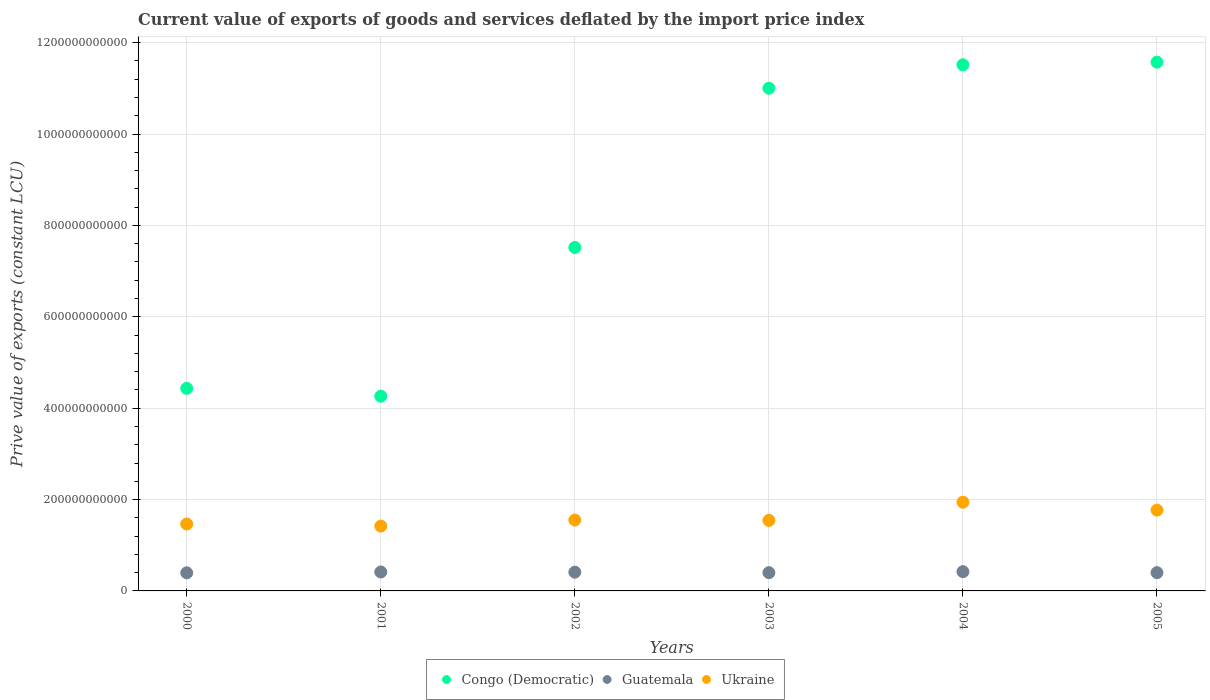What is the prive value of exports in Ukraine in 2002?
Your answer should be very brief. 1.55e+11. Across all years, what is the maximum prive value of exports in Ukraine?
Your response must be concise. 1.94e+11. Across all years, what is the minimum prive value of exports in Guatemala?
Offer a very short reply. 3.96e+1. In which year was the prive value of exports in Congo (Democratic) minimum?
Provide a succinct answer. 2001. What is the total prive value of exports in Guatemala in the graph?
Offer a terse response. 2.44e+11. What is the difference between the prive value of exports in Ukraine in 2001 and that in 2003?
Make the answer very short. -1.25e+1. What is the difference between the prive value of exports in Guatemala in 2005 and the prive value of exports in Ukraine in 2001?
Provide a short and direct response. -1.02e+11. What is the average prive value of exports in Congo (Democratic) per year?
Offer a terse response. 8.38e+11. In the year 2004, what is the difference between the prive value of exports in Guatemala and prive value of exports in Congo (Democratic)?
Provide a succinct answer. -1.11e+12. In how many years, is the prive value of exports in Guatemala greater than 640000000000 LCU?
Give a very brief answer. 0. What is the ratio of the prive value of exports in Guatemala in 2001 to that in 2003?
Provide a short and direct response. 1.04. Is the difference between the prive value of exports in Guatemala in 2000 and 2001 greater than the difference between the prive value of exports in Congo (Democratic) in 2000 and 2001?
Provide a succinct answer. No. What is the difference between the highest and the second highest prive value of exports in Guatemala?
Keep it short and to the point. 7.23e+08. What is the difference between the highest and the lowest prive value of exports in Congo (Democratic)?
Ensure brevity in your answer.  7.31e+11. In how many years, is the prive value of exports in Congo (Democratic) greater than the average prive value of exports in Congo (Democratic) taken over all years?
Ensure brevity in your answer.  3. Is the prive value of exports in Congo (Democratic) strictly greater than the prive value of exports in Guatemala over the years?
Make the answer very short. Yes. How many dotlines are there?
Your answer should be compact. 3. What is the difference between two consecutive major ticks on the Y-axis?
Give a very brief answer. 2.00e+11. Does the graph contain grids?
Provide a short and direct response. Yes. Where does the legend appear in the graph?
Provide a short and direct response. Bottom center. How many legend labels are there?
Offer a very short reply. 3. How are the legend labels stacked?
Ensure brevity in your answer.  Horizontal. What is the title of the graph?
Keep it short and to the point. Current value of exports of goods and services deflated by the import price index. Does "South Asia" appear as one of the legend labels in the graph?
Give a very brief answer. No. What is the label or title of the X-axis?
Provide a short and direct response. Years. What is the label or title of the Y-axis?
Ensure brevity in your answer.  Prive value of exports (constant LCU). What is the Prive value of exports (constant LCU) of Congo (Democratic) in 2000?
Offer a very short reply. 4.43e+11. What is the Prive value of exports (constant LCU) of Guatemala in 2000?
Your answer should be very brief. 3.96e+1. What is the Prive value of exports (constant LCU) of Ukraine in 2000?
Offer a terse response. 1.47e+11. What is the Prive value of exports (constant LCU) in Congo (Democratic) in 2001?
Keep it short and to the point. 4.26e+11. What is the Prive value of exports (constant LCU) in Guatemala in 2001?
Your answer should be very brief. 4.15e+1. What is the Prive value of exports (constant LCU) of Ukraine in 2001?
Keep it short and to the point. 1.42e+11. What is the Prive value of exports (constant LCU) in Congo (Democratic) in 2002?
Your answer should be very brief. 7.52e+11. What is the Prive value of exports (constant LCU) in Guatemala in 2002?
Provide a short and direct response. 4.10e+1. What is the Prive value of exports (constant LCU) of Ukraine in 2002?
Your response must be concise. 1.55e+11. What is the Prive value of exports (constant LCU) of Congo (Democratic) in 2003?
Give a very brief answer. 1.10e+12. What is the Prive value of exports (constant LCU) in Guatemala in 2003?
Your answer should be very brief. 4.00e+1. What is the Prive value of exports (constant LCU) of Ukraine in 2003?
Your response must be concise. 1.54e+11. What is the Prive value of exports (constant LCU) in Congo (Democratic) in 2004?
Give a very brief answer. 1.15e+12. What is the Prive value of exports (constant LCU) in Guatemala in 2004?
Ensure brevity in your answer.  4.22e+1. What is the Prive value of exports (constant LCU) of Ukraine in 2004?
Provide a short and direct response. 1.94e+11. What is the Prive value of exports (constant LCU) of Congo (Democratic) in 2005?
Provide a succinct answer. 1.16e+12. What is the Prive value of exports (constant LCU) in Guatemala in 2005?
Your answer should be compact. 4.00e+1. What is the Prive value of exports (constant LCU) of Ukraine in 2005?
Provide a succinct answer. 1.77e+11. Across all years, what is the maximum Prive value of exports (constant LCU) in Congo (Democratic)?
Your answer should be compact. 1.16e+12. Across all years, what is the maximum Prive value of exports (constant LCU) in Guatemala?
Your answer should be compact. 4.22e+1. Across all years, what is the maximum Prive value of exports (constant LCU) of Ukraine?
Offer a terse response. 1.94e+11. Across all years, what is the minimum Prive value of exports (constant LCU) in Congo (Democratic)?
Give a very brief answer. 4.26e+11. Across all years, what is the minimum Prive value of exports (constant LCU) of Guatemala?
Offer a terse response. 3.96e+1. Across all years, what is the minimum Prive value of exports (constant LCU) in Ukraine?
Ensure brevity in your answer.  1.42e+11. What is the total Prive value of exports (constant LCU) of Congo (Democratic) in the graph?
Provide a short and direct response. 5.03e+12. What is the total Prive value of exports (constant LCU) of Guatemala in the graph?
Provide a short and direct response. 2.44e+11. What is the total Prive value of exports (constant LCU) of Ukraine in the graph?
Offer a very short reply. 9.69e+11. What is the difference between the Prive value of exports (constant LCU) of Congo (Democratic) in 2000 and that in 2001?
Your answer should be compact. 1.71e+1. What is the difference between the Prive value of exports (constant LCU) in Guatemala in 2000 and that in 2001?
Your response must be concise. -1.82e+09. What is the difference between the Prive value of exports (constant LCU) of Ukraine in 2000 and that in 2001?
Offer a very short reply. 4.68e+09. What is the difference between the Prive value of exports (constant LCU) of Congo (Democratic) in 2000 and that in 2002?
Provide a short and direct response. -3.08e+11. What is the difference between the Prive value of exports (constant LCU) of Guatemala in 2000 and that in 2002?
Make the answer very short. -1.37e+09. What is the difference between the Prive value of exports (constant LCU) in Ukraine in 2000 and that in 2002?
Your response must be concise. -8.59e+09. What is the difference between the Prive value of exports (constant LCU) of Congo (Democratic) in 2000 and that in 2003?
Give a very brief answer. -6.57e+11. What is the difference between the Prive value of exports (constant LCU) of Guatemala in 2000 and that in 2003?
Give a very brief answer. -3.15e+08. What is the difference between the Prive value of exports (constant LCU) of Ukraine in 2000 and that in 2003?
Offer a very short reply. -7.83e+09. What is the difference between the Prive value of exports (constant LCU) of Congo (Democratic) in 2000 and that in 2004?
Provide a succinct answer. -7.08e+11. What is the difference between the Prive value of exports (constant LCU) of Guatemala in 2000 and that in 2004?
Offer a terse response. -2.54e+09. What is the difference between the Prive value of exports (constant LCU) of Ukraine in 2000 and that in 2004?
Give a very brief answer. -4.77e+1. What is the difference between the Prive value of exports (constant LCU) of Congo (Democratic) in 2000 and that in 2005?
Provide a succinct answer. -7.14e+11. What is the difference between the Prive value of exports (constant LCU) of Guatemala in 2000 and that in 2005?
Make the answer very short. -3.69e+08. What is the difference between the Prive value of exports (constant LCU) of Ukraine in 2000 and that in 2005?
Keep it short and to the point. -3.03e+1. What is the difference between the Prive value of exports (constant LCU) of Congo (Democratic) in 2001 and that in 2002?
Your answer should be very brief. -3.26e+11. What is the difference between the Prive value of exports (constant LCU) in Guatemala in 2001 and that in 2002?
Your answer should be very brief. 4.46e+08. What is the difference between the Prive value of exports (constant LCU) in Ukraine in 2001 and that in 2002?
Make the answer very short. -1.33e+1. What is the difference between the Prive value of exports (constant LCU) in Congo (Democratic) in 2001 and that in 2003?
Your answer should be very brief. -6.74e+11. What is the difference between the Prive value of exports (constant LCU) in Guatemala in 2001 and that in 2003?
Make the answer very short. 1.50e+09. What is the difference between the Prive value of exports (constant LCU) in Ukraine in 2001 and that in 2003?
Make the answer very short. -1.25e+1. What is the difference between the Prive value of exports (constant LCU) in Congo (Democratic) in 2001 and that in 2004?
Your response must be concise. -7.25e+11. What is the difference between the Prive value of exports (constant LCU) in Guatemala in 2001 and that in 2004?
Provide a succinct answer. -7.23e+08. What is the difference between the Prive value of exports (constant LCU) in Ukraine in 2001 and that in 2004?
Offer a terse response. -5.24e+1. What is the difference between the Prive value of exports (constant LCU) in Congo (Democratic) in 2001 and that in 2005?
Keep it short and to the point. -7.31e+11. What is the difference between the Prive value of exports (constant LCU) of Guatemala in 2001 and that in 2005?
Your answer should be compact. 1.45e+09. What is the difference between the Prive value of exports (constant LCU) of Ukraine in 2001 and that in 2005?
Offer a terse response. -3.50e+1. What is the difference between the Prive value of exports (constant LCU) of Congo (Democratic) in 2002 and that in 2003?
Keep it short and to the point. -3.49e+11. What is the difference between the Prive value of exports (constant LCU) in Guatemala in 2002 and that in 2003?
Make the answer very short. 1.06e+09. What is the difference between the Prive value of exports (constant LCU) of Ukraine in 2002 and that in 2003?
Your answer should be compact. 7.55e+08. What is the difference between the Prive value of exports (constant LCU) in Congo (Democratic) in 2002 and that in 2004?
Your response must be concise. -4.00e+11. What is the difference between the Prive value of exports (constant LCU) of Guatemala in 2002 and that in 2004?
Ensure brevity in your answer.  -1.17e+09. What is the difference between the Prive value of exports (constant LCU) in Ukraine in 2002 and that in 2004?
Give a very brief answer. -3.91e+1. What is the difference between the Prive value of exports (constant LCU) of Congo (Democratic) in 2002 and that in 2005?
Give a very brief answer. -4.06e+11. What is the difference between the Prive value of exports (constant LCU) in Guatemala in 2002 and that in 2005?
Your response must be concise. 1.01e+09. What is the difference between the Prive value of exports (constant LCU) of Ukraine in 2002 and that in 2005?
Offer a very short reply. -2.17e+1. What is the difference between the Prive value of exports (constant LCU) in Congo (Democratic) in 2003 and that in 2004?
Your answer should be very brief. -5.13e+1. What is the difference between the Prive value of exports (constant LCU) in Guatemala in 2003 and that in 2004?
Provide a short and direct response. -2.23e+09. What is the difference between the Prive value of exports (constant LCU) in Ukraine in 2003 and that in 2004?
Your response must be concise. -3.98e+1. What is the difference between the Prive value of exports (constant LCU) of Congo (Democratic) in 2003 and that in 2005?
Make the answer very short. -5.72e+1. What is the difference between the Prive value of exports (constant LCU) in Guatemala in 2003 and that in 2005?
Your response must be concise. -5.38e+07. What is the difference between the Prive value of exports (constant LCU) of Ukraine in 2003 and that in 2005?
Ensure brevity in your answer.  -2.25e+1. What is the difference between the Prive value of exports (constant LCU) of Congo (Democratic) in 2004 and that in 2005?
Keep it short and to the point. -5.86e+09. What is the difference between the Prive value of exports (constant LCU) in Guatemala in 2004 and that in 2005?
Ensure brevity in your answer.  2.17e+09. What is the difference between the Prive value of exports (constant LCU) of Ukraine in 2004 and that in 2005?
Provide a succinct answer. 1.74e+1. What is the difference between the Prive value of exports (constant LCU) in Congo (Democratic) in 2000 and the Prive value of exports (constant LCU) in Guatemala in 2001?
Keep it short and to the point. 4.02e+11. What is the difference between the Prive value of exports (constant LCU) of Congo (Democratic) in 2000 and the Prive value of exports (constant LCU) of Ukraine in 2001?
Provide a succinct answer. 3.01e+11. What is the difference between the Prive value of exports (constant LCU) of Guatemala in 2000 and the Prive value of exports (constant LCU) of Ukraine in 2001?
Keep it short and to the point. -1.02e+11. What is the difference between the Prive value of exports (constant LCU) in Congo (Democratic) in 2000 and the Prive value of exports (constant LCU) in Guatemala in 2002?
Ensure brevity in your answer.  4.02e+11. What is the difference between the Prive value of exports (constant LCU) of Congo (Democratic) in 2000 and the Prive value of exports (constant LCU) of Ukraine in 2002?
Your answer should be compact. 2.88e+11. What is the difference between the Prive value of exports (constant LCU) in Guatemala in 2000 and the Prive value of exports (constant LCU) in Ukraine in 2002?
Your answer should be very brief. -1.16e+11. What is the difference between the Prive value of exports (constant LCU) in Congo (Democratic) in 2000 and the Prive value of exports (constant LCU) in Guatemala in 2003?
Make the answer very short. 4.03e+11. What is the difference between the Prive value of exports (constant LCU) in Congo (Democratic) in 2000 and the Prive value of exports (constant LCU) in Ukraine in 2003?
Provide a short and direct response. 2.89e+11. What is the difference between the Prive value of exports (constant LCU) in Guatemala in 2000 and the Prive value of exports (constant LCU) in Ukraine in 2003?
Give a very brief answer. -1.15e+11. What is the difference between the Prive value of exports (constant LCU) of Congo (Democratic) in 2000 and the Prive value of exports (constant LCU) of Guatemala in 2004?
Make the answer very short. 4.01e+11. What is the difference between the Prive value of exports (constant LCU) in Congo (Democratic) in 2000 and the Prive value of exports (constant LCU) in Ukraine in 2004?
Your answer should be compact. 2.49e+11. What is the difference between the Prive value of exports (constant LCU) in Guatemala in 2000 and the Prive value of exports (constant LCU) in Ukraine in 2004?
Keep it short and to the point. -1.55e+11. What is the difference between the Prive value of exports (constant LCU) in Congo (Democratic) in 2000 and the Prive value of exports (constant LCU) in Guatemala in 2005?
Keep it short and to the point. 4.03e+11. What is the difference between the Prive value of exports (constant LCU) of Congo (Democratic) in 2000 and the Prive value of exports (constant LCU) of Ukraine in 2005?
Give a very brief answer. 2.67e+11. What is the difference between the Prive value of exports (constant LCU) in Guatemala in 2000 and the Prive value of exports (constant LCU) in Ukraine in 2005?
Your response must be concise. -1.37e+11. What is the difference between the Prive value of exports (constant LCU) of Congo (Democratic) in 2001 and the Prive value of exports (constant LCU) of Guatemala in 2002?
Your answer should be compact. 3.85e+11. What is the difference between the Prive value of exports (constant LCU) in Congo (Democratic) in 2001 and the Prive value of exports (constant LCU) in Ukraine in 2002?
Your answer should be compact. 2.71e+11. What is the difference between the Prive value of exports (constant LCU) in Guatemala in 2001 and the Prive value of exports (constant LCU) in Ukraine in 2002?
Your answer should be compact. -1.14e+11. What is the difference between the Prive value of exports (constant LCU) in Congo (Democratic) in 2001 and the Prive value of exports (constant LCU) in Guatemala in 2003?
Provide a succinct answer. 3.86e+11. What is the difference between the Prive value of exports (constant LCU) of Congo (Democratic) in 2001 and the Prive value of exports (constant LCU) of Ukraine in 2003?
Your answer should be very brief. 2.72e+11. What is the difference between the Prive value of exports (constant LCU) of Guatemala in 2001 and the Prive value of exports (constant LCU) of Ukraine in 2003?
Offer a very short reply. -1.13e+11. What is the difference between the Prive value of exports (constant LCU) in Congo (Democratic) in 2001 and the Prive value of exports (constant LCU) in Guatemala in 2004?
Provide a succinct answer. 3.84e+11. What is the difference between the Prive value of exports (constant LCU) of Congo (Democratic) in 2001 and the Prive value of exports (constant LCU) of Ukraine in 2004?
Provide a short and direct response. 2.32e+11. What is the difference between the Prive value of exports (constant LCU) of Guatemala in 2001 and the Prive value of exports (constant LCU) of Ukraine in 2004?
Keep it short and to the point. -1.53e+11. What is the difference between the Prive value of exports (constant LCU) in Congo (Democratic) in 2001 and the Prive value of exports (constant LCU) in Guatemala in 2005?
Your answer should be compact. 3.86e+11. What is the difference between the Prive value of exports (constant LCU) of Congo (Democratic) in 2001 and the Prive value of exports (constant LCU) of Ukraine in 2005?
Offer a very short reply. 2.49e+11. What is the difference between the Prive value of exports (constant LCU) of Guatemala in 2001 and the Prive value of exports (constant LCU) of Ukraine in 2005?
Offer a terse response. -1.35e+11. What is the difference between the Prive value of exports (constant LCU) in Congo (Democratic) in 2002 and the Prive value of exports (constant LCU) in Guatemala in 2003?
Provide a succinct answer. 7.12e+11. What is the difference between the Prive value of exports (constant LCU) in Congo (Democratic) in 2002 and the Prive value of exports (constant LCU) in Ukraine in 2003?
Make the answer very short. 5.97e+11. What is the difference between the Prive value of exports (constant LCU) in Guatemala in 2002 and the Prive value of exports (constant LCU) in Ukraine in 2003?
Offer a terse response. -1.13e+11. What is the difference between the Prive value of exports (constant LCU) in Congo (Democratic) in 2002 and the Prive value of exports (constant LCU) in Guatemala in 2004?
Provide a succinct answer. 7.10e+11. What is the difference between the Prive value of exports (constant LCU) in Congo (Democratic) in 2002 and the Prive value of exports (constant LCU) in Ukraine in 2004?
Offer a terse response. 5.58e+11. What is the difference between the Prive value of exports (constant LCU) in Guatemala in 2002 and the Prive value of exports (constant LCU) in Ukraine in 2004?
Ensure brevity in your answer.  -1.53e+11. What is the difference between the Prive value of exports (constant LCU) of Congo (Democratic) in 2002 and the Prive value of exports (constant LCU) of Guatemala in 2005?
Offer a terse response. 7.12e+11. What is the difference between the Prive value of exports (constant LCU) of Congo (Democratic) in 2002 and the Prive value of exports (constant LCU) of Ukraine in 2005?
Keep it short and to the point. 5.75e+11. What is the difference between the Prive value of exports (constant LCU) in Guatemala in 2002 and the Prive value of exports (constant LCU) in Ukraine in 2005?
Ensure brevity in your answer.  -1.36e+11. What is the difference between the Prive value of exports (constant LCU) in Congo (Democratic) in 2003 and the Prive value of exports (constant LCU) in Guatemala in 2004?
Offer a very short reply. 1.06e+12. What is the difference between the Prive value of exports (constant LCU) in Congo (Democratic) in 2003 and the Prive value of exports (constant LCU) in Ukraine in 2004?
Make the answer very short. 9.06e+11. What is the difference between the Prive value of exports (constant LCU) in Guatemala in 2003 and the Prive value of exports (constant LCU) in Ukraine in 2004?
Provide a succinct answer. -1.54e+11. What is the difference between the Prive value of exports (constant LCU) of Congo (Democratic) in 2003 and the Prive value of exports (constant LCU) of Guatemala in 2005?
Offer a very short reply. 1.06e+12. What is the difference between the Prive value of exports (constant LCU) of Congo (Democratic) in 2003 and the Prive value of exports (constant LCU) of Ukraine in 2005?
Your answer should be compact. 9.23e+11. What is the difference between the Prive value of exports (constant LCU) in Guatemala in 2003 and the Prive value of exports (constant LCU) in Ukraine in 2005?
Your answer should be compact. -1.37e+11. What is the difference between the Prive value of exports (constant LCU) of Congo (Democratic) in 2004 and the Prive value of exports (constant LCU) of Guatemala in 2005?
Provide a short and direct response. 1.11e+12. What is the difference between the Prive value of exports (constant LCU) in Congo (Democratic) in 2004 and the Prive value of exports (constant LCU) in Ukraine in 2005?
Give a very brief answer. 9.75e+11. What is the difference between the Prive value of exports (constant LCU) of Guatemala in 2004 and the Prive value of exports (constant LCU) of Ukraine in 2005?
Make the answer very short. -1.35e+11. What is the average Prive value of exports (constant LCU) in Congo (Democratic) per year?
Ensure brevity in your answer.  8.38e+11. What is the average Prive value of exports (constant LCU) in Guatemala per year?
Keep it short and to the point. 4.07e+1. What is the average Prive value of exports (constant LCU) of Ukraine per year?
Give a very brief answer. 1.62e+11. In the year 2000, what is the difference between the Prive value of exports (constant LCU) of Congo (Democratic) and Prive value of exports (constant LCU) of Guatemala?
Your answer should be compact. 4.04e+11. In the year 2000, what is the difference between the Prive value of exports (constant LCU) of Congo (Democratic) and Prive value of exports (constant LCU) of Ukraine?
Provide a succinct answer. 2.97e+11. In the year 2000, what is the difference between the Prive value of exports (constant LCU) in Guatemala and Prive value of exports (constant LCU) in Ukraine?
Keep it short and to the point. -1.07e+11. In the year 2001, what is the difference between the Prive value of exports (constant LCU) in Congo (Democratic) and Prive value of exports (constant LCU) in Guatemala?
Make the answer very short. 3.85e+11. In the year 2001, what is the difference between the Prive value of exports (constant LCU) of Congo (Democratic) and Prive value of exports (constant LCU) of Ukraine?
Your answer should be compact. 2.84e+11. In the year 2001, what is the difference between the Prive value of exports (constant LCU) in Guatemala and Prive value of exports (constant LCU) in Ukraine?
Keep it short and to the point. -1.00e+11. In the year 2002, what is the difference between the Prive value of exports (constant LCU) of Congo (Democratic) and Prive value of exports (constant LCU) of Guatemala?
Your answer should be compact. 7.11e+11. In the year 2002, what is the difference between the Prive value of exports (constant LCU) in Congo (Democratic) and Prive value of exports (constant LCU) in Ukraine?
Your response must be concise. 5.97e+11. In the year 2002, what is the difference between the Prive value of exports (constant LCU) in Guatemala and Prive value of exports (constant LCU) in Ukraine?
Your answer should be very brief. -1.14e+11. In the year 2003, what is the difference between the Prive value of exports (constant LCU) in Congo (Democratic) and Prive value of exports (constant LCU) in Guatemala?
Offer a very short reply. 1.06e+12. In the year 2003, what is the difference between the Prive value of exports (constant LCU) of Congo (Democratic) and Prive value of exports (constant LCU) of Ukraine?
Your answer should be compact. 9.46e+11. In the year 2003, what is the difference between the Prive value of exports (constant LCU) in Guatemala and Prive value of exports (constant LCU) in Ukraine?
Your response must be concise. -1.14e+11. In the year 2004, what is the difference between the Prive value of exports (constant LCU) in Congo (Democratic) and Prive value of exports (constant LCU) in Guatemala?
Offer a terse response. 1.11e+12. In the year 2004, what is the difference between the Prive value of exports (constant LCU) in Congo (Democratic) and Prive value of exports (constant LCU) in Ukraine?
Offer a terse response. 9.57e+11. In the year 2004, what is the difference between the Prive value of exports (constant LCU) of Guatemala and Prive value of exports (constant LCU) of Ukraine?
Offer a terse response. -1.52e+11. In the year 2005, what is the difference between the Prive value of exports (constant LCU) of Congo (Democratic) and Prive value of exports (constant LCU) of Guatemala?
Your answer should be compact. 1.12e+12. In the year 2005, what is the difference between the Prive value of exports (constant LCU) of Congo (Democratic) and Prive value of exports (constant LCU) of Ukraine?
Offer a very short reply. 9.81e+11. In the year 2005, what is the difference between the Prive value of exports (constant LCU) in Guatemala and Prive value of exports (constant LCU) in Ukraine?
Keep it short and to the point. -1.37e+11. What is the ratio of the Prive value of exports (constant LCU) in Congo (Democratic) in 2000 to that in 2001?
Ensure brevity in your answer.  1.04. What is the ratio of the Prive value of exports (constant LCU) of Guatemala in 2000 to that in 2001?
Provide a short and direct response. 0.96. What is the ratio of the Prive value of exports (constant LCU) in Ukraine in 2000 to that in 2001?
Ensure brevity in your answer.  1.03. What is the ratio of the Prive value of exports (constant LCU) of Congo (Democratic) in 2000 to that in 2002?
Ensure brevity in your answer.  0.59. What is the ratio of the Prive value of exports (constant LCU) of Guatemala in 2000 to that in 2002?
Provide a short and direct response. 0.97. What is the ratio of the Prive value of exports (constant LCU) of Ukraine in 2000 to that in 2002?
Make the answer very short. 0.94. What is the ratio of the Prive value of exports (constant LCU) in Congo (Democratic) in 2000 to that in 2003?
Your answer should be compact. 0.4. What is the ratio of the Prive value of exports (constant LCU) in Guatemala in 2000 to that in 2003?
Keep it short and to the point. 0.99. What is the ratio of the Prive value of exports (constant LCU) of Ukraine in 2000 to that in 2003?
Give a very brief answer. 0.95. What is the ratio of the Prive value of exports (constant LCU) of Congo (Democratic) in 2000 to that in 2004?
Offer a very short reply. 0.39. What is the ratio of the Prive value of exports (constant LCU) in Guatemala in 2000 to that in 2004?
Your response must be concise. 0.94. What is the ratio of the Prive value of exports (constant LCU) of Ukraine in 2000 to that in 2004?
Give a very brief answer. 0.75. What is the ratio of the Prive value of exports (constant LCU) in Congo (Democratic) in 2000 to that in 2005?
Make the answer very short. 0.38. What is the ratio of the Prive value of exports (constant LCU) of Ukraine in 2000 to that in 2005?
Your answer should be very brief. 0.83. What is the ratio of the Prive value of exports (constant LCU) in Congo (Democratic) in 2001 to that in 2002?
Offer a terse response. 0.57. What is the ratio of the Prive value of exports (constant LCU) of Guatemala in 2001 to that in 2002?
Give a very brief answer. 1.01. What is the ratio of the Prive value of exports (constant LCU) in Ukraine in 2001 to that in 2002?
Your answer should be very brief. 0.91. What is the ratio of the Prive value of exports (constant LCU) of Congo (Democratic) in 2001 to that in 2003?
Ensure brevity in your answer.  0.39. What is the ratio of the Prive value of exports (constant LCU) in Guatemala in 2001 to that in 2003?
Your answer should be very brief. 1.04. What is the ratio of the Prive value of exports (constant LCU) of Ukraine in 2001 to that in 2003?
Make the answer very short. 0.92. What is the ratio of the Prive value of exports (constant LCU) in Congo (Democratic) in 2001 to that in 2004?
Make the answer very short. 0.37. What is the ratio of the Prive value of exports (constant LCU) of Guatemala in 2001 to that in 2004?
Keep it short and to the point. 0.98. What is the ratio of the Prive value of exports (constant LCU) in Ukraine in 2001 to that in 2004?
Your answer should be compact. 0.73. What is the ratio of the Prive value of exports (constant LCU) in Congo (Democratic) in 2001 to that in 2005?
Keep it short and to the point. 0.37. What is the ratio of the Prive value of exports (constant LCU) in Guatemala in 2001 to that in 2005?
Provide a short and direct response. 1.04. What is the ratio of the Prive value of exports (constant LCU) of Ukraine in 2001 to that in 2005?
Keep it short and to the point. 0.8. What is the ratio of the Prive value of exports (constant LCU) of Congo (Democratic) in 2002 to that in 2003?
Offer a very short reply. 0.68. What is the ratio of the Prive value of exports (constant LCU) of Guatemala in 2002 to that in 2003?
Keep it short and to the point. 1.03. What is the ratio of the Prive value of exports (constant LCU) in Congo (Democratic) in 2002 to that in 2004?
Offer a very short reply. 0.65. What is the ratio of the Prive value of exports (constant LCU) in Guatemala in 2002 to that in 2004?
Keep it short and to the point. 0.97. What is the ratio of the Prive value of exports (constant LCU) of Ukraine in 2002 to that in 2004?
Your answer should be very brief. 0.8. What is the ratio of the Prive value of exports (constant LCU) of Congo (Democratic) in 2002 to that in 2005?
Offer a terse response. 0.65. What is the ratio of the Prive value of exports (constant LCU) of Guatemala in 2002 to that in 2005?
Give a very brief answer. 1.03. What is the ratio of the Prive value of exports (constant LCU) of Ukraine in 2002 to that in 2005?
Keep it short and to the point. 0.88. What is the ratio of the Prive value of exports (constant LCU) in Congo (Democratic) in 2003 to that in 2004?
Your response must be concise. 0.96. What is the ratio of the Prive value of exports (constant LCU) of Guatemala in 2003 to that in 2004?
Offer a very short reply. 0.95. What is the ratio of the Prive value of exports (constant LCU) in Ukraine in 2003 to that in 2004?
Your answer should be compact. 0.79. What is the ratio of the Prive value of exports (constant LCU) of Congo (Democratic) in 2003 to that in 2005?
Ensure brevity in your answer.  0.95. What is the ratio of the Prive value of exports (constant LCU) in Guatemala in 2003 to that in 2005?
Ensure brevity in your answer.  1. What is the ratio of the Prive value of exports (constant LCU) of Ukraine in 2003 to that in 2005?
Ensure brevity in your answer.  0.87. What is the ratio of the Prive value of exports (constant LCU) in Guatemala in 2004 to that in 2005?
Offer a terse response. 1.05. What is the ratio of the Prive value of exports (constant LCU) of Ukraine in 2004 to that in 2005?
Keep it short and to the point. 1.1. What is the difference between the highest and the second highest Prive value of exports (constant LCU) of Congo (Democratic)?
Provide a succinct answer. 5.86e+09. What is the difference between the highest and the second highest Prive value of exports (constant LCU) in Guatemala?
Offer a terse response. 7.23e+08. What is the difference between the highest and the second highest Prive value of exports (constant LCU) of Ukraine?
Provide a succinct answer. 1.74e+1. What is the difference between the highest and the lowest Prive value of exports (constant LCU) in Congo (Democratic)?
Provide a short and direct response. 7.31e+11. What is the difference between the highest and the lowest Prive value of exports (constant LCU) of Guatemala?
Provide a short and direct response. 2.54e+09. What is the difference between the highest and the lowest Prive value of exports (constant LCU) of Ukraine?
Your answer should be compact. 5.24e+1. 